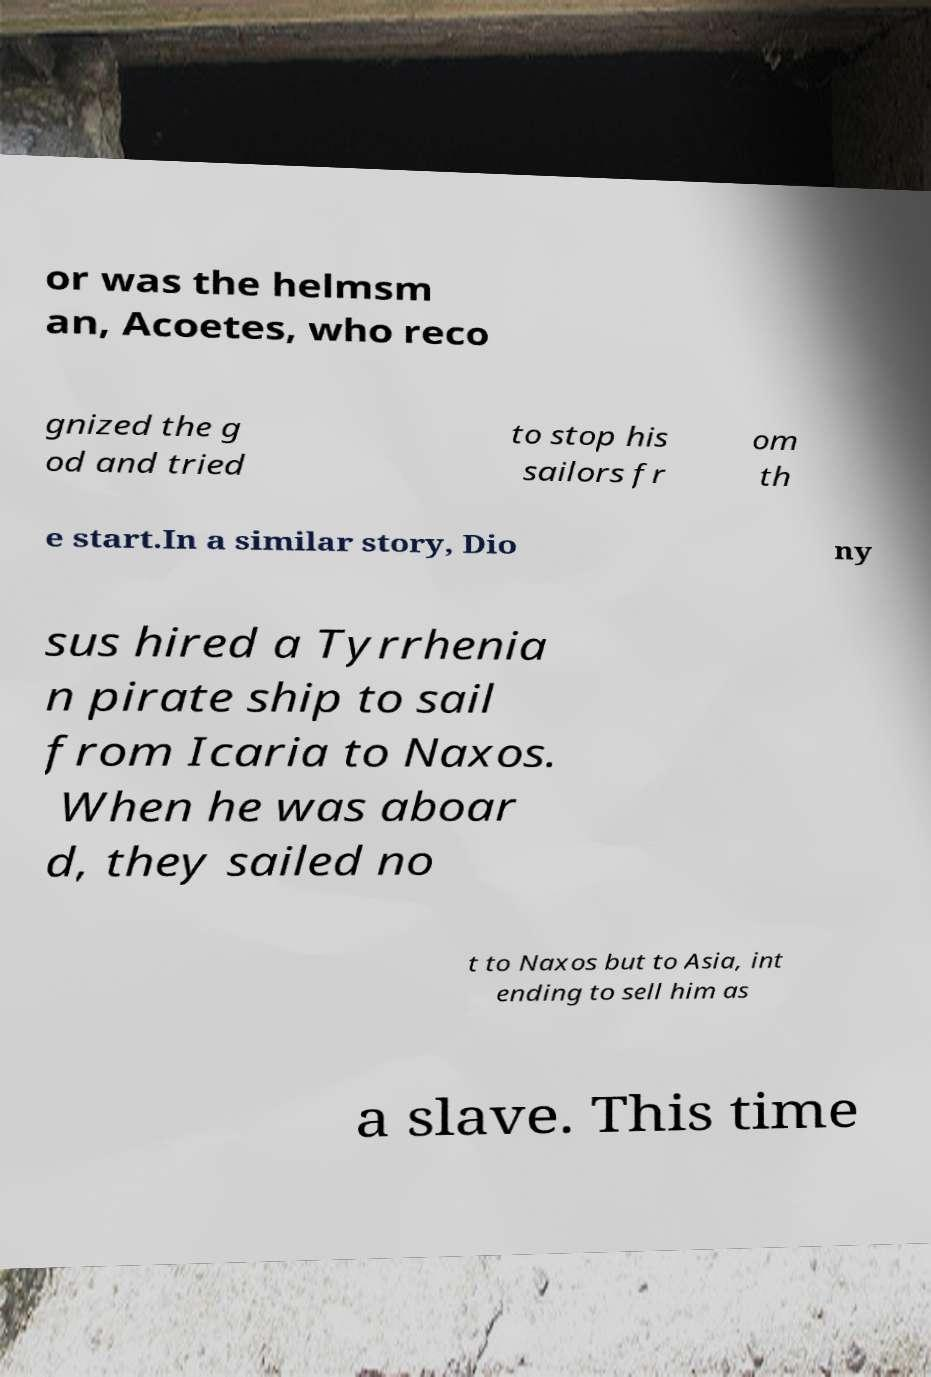Can you read and provide the text displayed in the image?This photo seems to have some interesting text. Can you extract and type it out for me? or was the helmsm an, Acoetes, who reco gnized the g od and tried to stop his sailors fr om th e start.In a similar story, Dio ny sus hired a Tyrrhenia n pirate ship to sail from Icaria to Naxos. When he was aboar d, they sailed no t to Naxos but to Asia, int ending to sell him as a slave. This time 